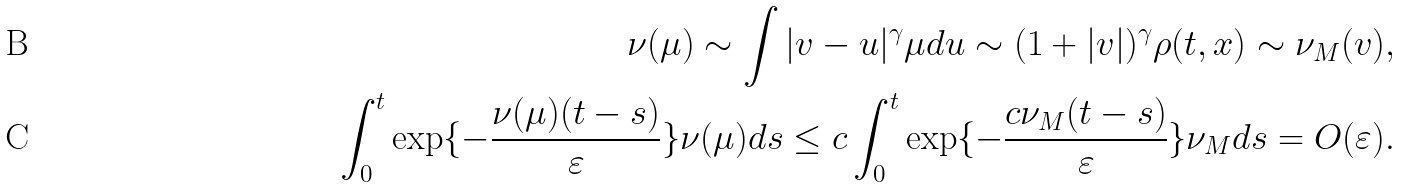Convert formula to latex. <formula><loc_0><loc_0><loc_500><loc_500>\nu ( \mu ) \sim \int | v - u | ^ { \gamma } \mu d u \sim ( 1 + | v | ) ^ { \gamma } \rho ( t , x ) \sim \nu _ { M } ( v ) , \\ \int _ { 0 } ^ { t } \exp \{ - \frac { \nu ( \mu ) ( t - s ) } { \varepsilon } \} \nu ( \mu ) d s \leq c \int _ { 0 } ^ { t } \exp \{ - \frac { c \nu _ { M } ( t - s ) } { \varepsilon } \} \nu _ { M } d s = O ( \varepsilon ) .</formula> 